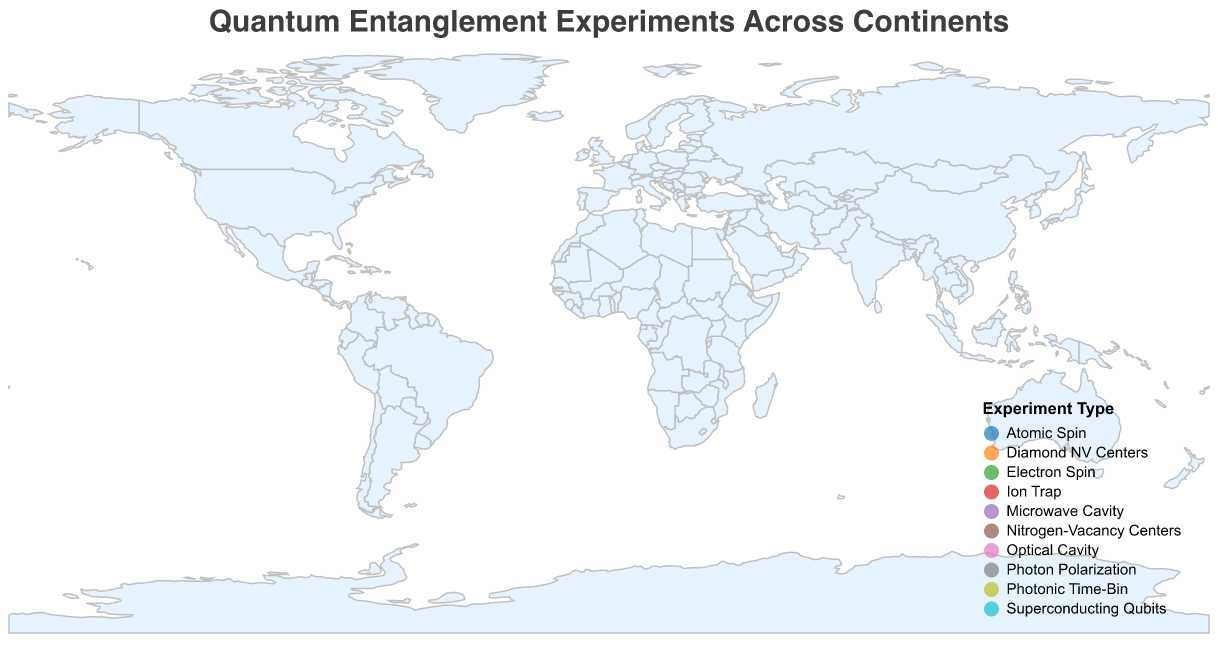What is the title of the plot? The main text at the top of the figure states the title.
Answer: Quantum Entanglement Experiments Across Continents How many continents are represented in the plot? Visual inspection of the figure shows markers on multiple continents visible in the geographic plot.
Answer: Six Which location has the highest success rate (%)? By observing the data points and the corresponding success rates shown in the tooltip or marker size, the location with the highest success rate is found.
Answer: Vienna (Austria) What is the average entanglement duration (μs) for all experiments conducted in Asia? Identify all experiments in Asia and average their entanglement duration values (2.1 + 2.3)/2.
Answer: 2.2 Compare the success rates of experiments in Europe and North America. Which continent has a higher average success rate? Calculate the average success rate for each continent and compare them. Europe: (98.2 + 97.4)/2 = 97.8, North America: (94.7 + 94.9)/2 = 94.8.
Answer: Europe What experiment type was conducted in Santiago (Chile)? Review the tooltip data or refer to the legend to find the experiment type associated with Santiago, Chile.
Answer: Photonic Time-Bin Which location is furthest from Vienna (Austria) in terms of distance (km)? By observing the tooltip data and the distance column, identify the location with the largest distance.
Answer: Canberra (Australia) What is the combined entanglement duration (μs) for all experiments in Australia? Sum all the entanglement duration values for the experiments in Australia: 1.2 + 1.1.
Answer: 2.3 How many different experiment types are represented in the plot? Review the legend or the tooltip data for all locations to count the number of unique experiment types.
Answer: Nine Which continent has the lowest average success rate (%) and what is that rate? Calculate the average success rate for each continent and identify the lowest value. Australia: (92.3 + 93.5)/2 = 92.9, Africa: 93.8, South America: 95.1, North America: (94.7 + 94.9)/2 = 94.8, Asia: (96.5 + 96.8)/2 = 96.65, Europe: (98.2 + 97.4)/2 = 97.8. The lowest average success rate is for Australia.
Answer: Australia, 92.9 